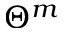Convert formula to latex. <formula><loc_0><loc_0><loc_500><loc_500>\Theta ^ { m }</formula> 